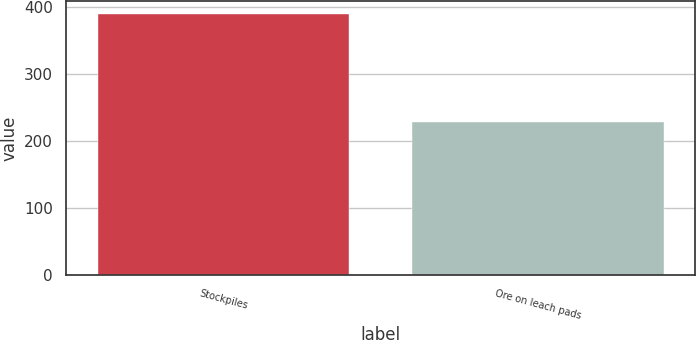<chart> <loc_0><loc_0><loc_500><loc_500><bar_chart><fcel>Stockpiles<fcel>Ore on leach pads<nl><fcel>389<fcel>228<nl></chart> 